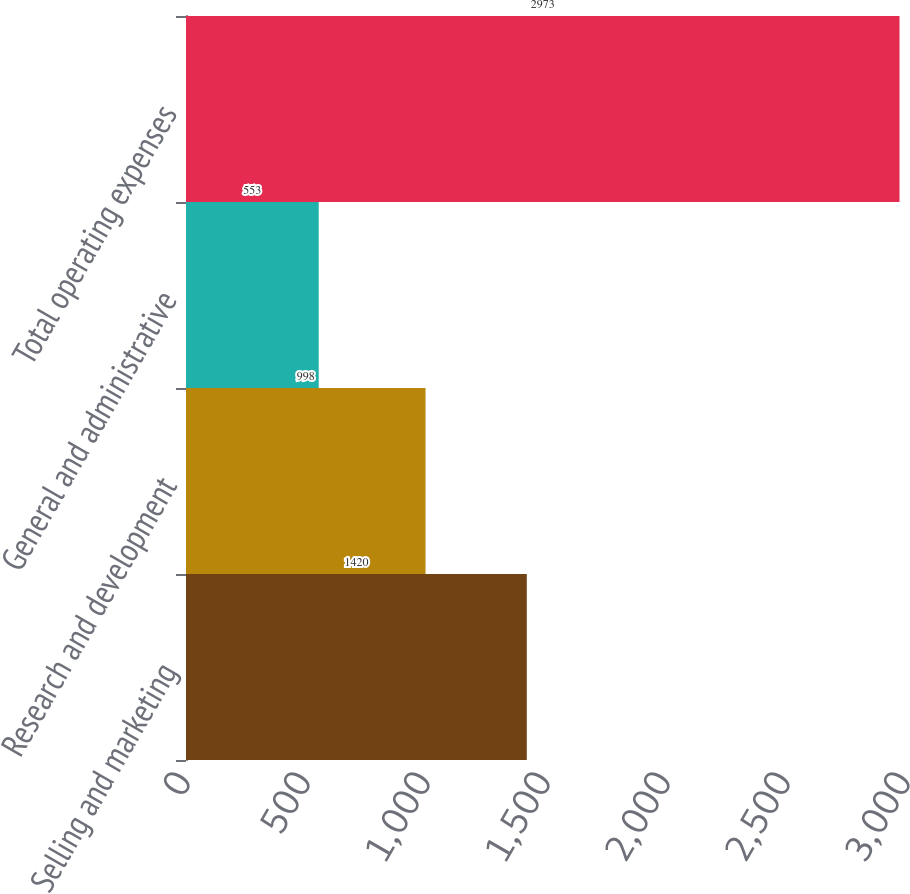Convert chart to OTSL. <chart><loc_0><loc_0><loc_500><loc_500><bar_chart><fcel>Selling and marketing<fcel>Research and development<fcel>General and administrative<fcel>Total operating expenses<nl><fcel>1420<fcel>998<fcel>553<fcel>2973<nl></chart> 